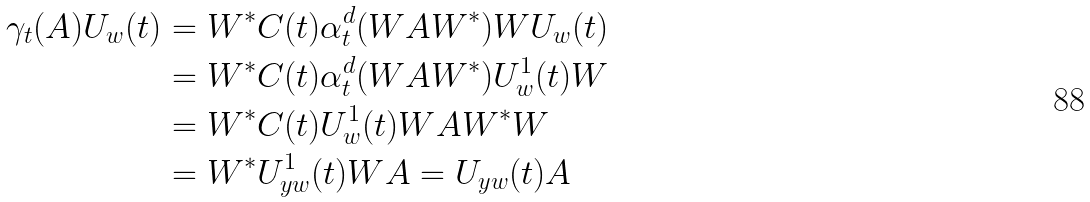<formula> <loc_0><loc_0><loc_500><loc_500>\gamma _ { t } ( A ) U _ { w } ( t ) & = W ^ { * } C ( t ) \alpha _ { t } ^ { d } ( W A W ^ { * } ) W U _ { w } ( t ) \\ & = W ^ { * } C ( t ) \alpha _ { t } ^ { d } ( W A W ^ { * } ) U _ { w } ^ { 1 } ( t ) W \\ & = W ^ { * } C ( t ) U _ { w } ^ { 1 } ( t ) W A W ^ { * } W \\ & = W ^ { * } U _ { y w } ^ { 1 } ( t ) W A = U _ { y w } ( t ) A</formula> 